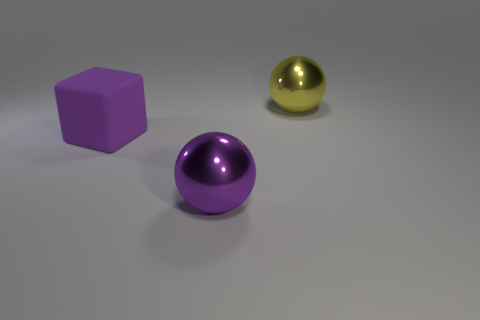What number of purple objects are the same shape as the yellow object?
Give a very brief answer. 1. Is there a big object that has the same material as the purple cube?
Offer a terse response. No. What material is the large sphere that is in front of the sphere behind the big block?
Ensure brevity in your answer.  Metal. There is a metal thing that is in front of the yellow metallic object; what size is it?
Your answer should be very brief. Large. Do the big rubber cube and the object that is in front of the matte thing have the same color?
Your answer should be compact. Yes. Are there any balls that have the same color as the large rubber cube?
Your answer should be compact. Yes. Do the big cube and the thing right of the purple metal object have the same material?
Your answer should be very brief. No. What number of tiny things are either yellow metal objects or yellow matte balls?
Give a very brief answer. 0. What is the material of the other object that is the same color as the big matte object?
Make the answer very short. Metal. Is the number of purple matte things less than the number of tiny green things?
Offer a terse response. No. 